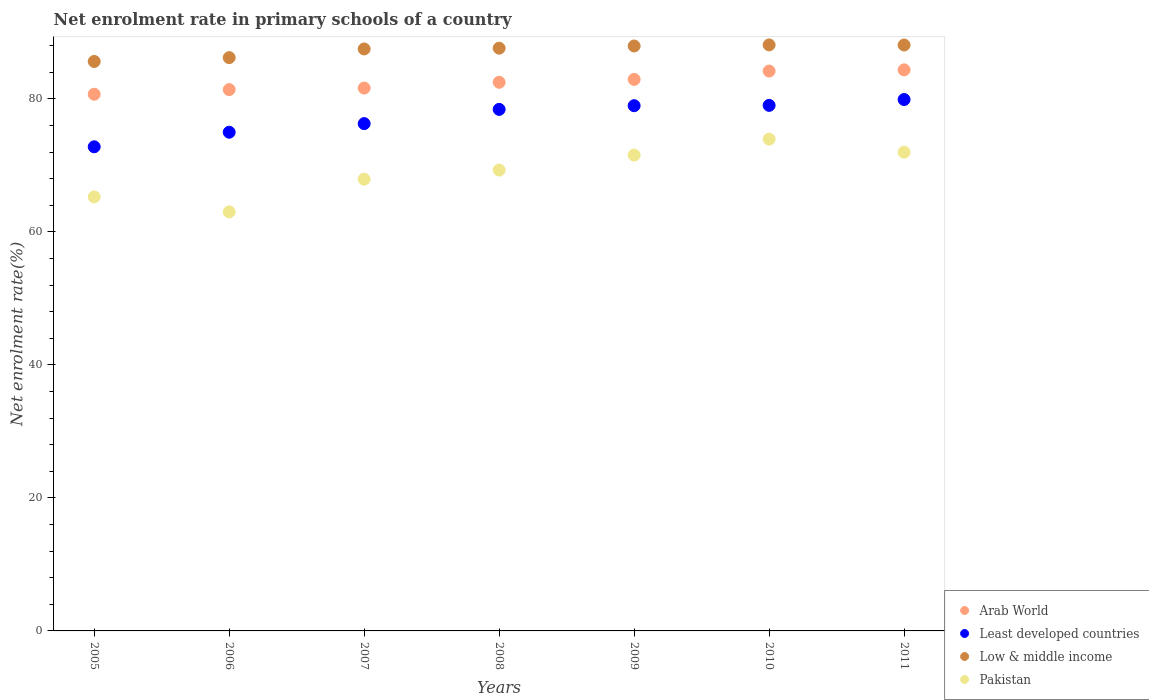Is the number of dotlines equal to the number of legend labels?
Make the answer very short. Yes. What is the net enrolment rate in primary schools in Least developed countries in 2005?
Give a very brief answer. 72.8. Across all years, what is the maximum net enrolment rate in primary schools in Pakistan?
Make the answer very short. 73.95. Across all years, what is the minimum net enrolment rate in primary schools in Pakistan?
Your response must be concise. 63.01. In which year was the net enrolment rate in primary schools in Least developed countries maximum?
Provide a succinct answer. 2011. In which year was the net enrolment rate in primary schools in Least developed countries minimum?
Ensure brevity in your answer.  2005. What is the total net enrolment rate in primary schools in Least developed countries in the graph?
Offer a very short reply. 540.4. What is the difference between the net enrolment rate in primary schools in Pakistan in 2005 and that in 2009?
Make the answer very short. -6.28. What is the difference between the net enrolment rate in primary schools in Low & middle income in 2011 and the net enrolment rate in primary schools in Pakistan in 2009?
Your answer should be very brief. 16.55. What is the average net enrolment rate in primary schools in Low & middle income per year?
Your answer should be compact. 87.31. In the year 2009, what is the difference between the net enrolment rate in primary schools in Arab World and net enrolment rate in primary schools in Least developed countries?
Provide a succinct answer. 3.96. In how many years, is the net enrolment rate in primary schools in Arab World greater than 20 %?
Offer a terse response. 7. What is the ratio of the net enrolment rate in primary schools in Pakistan in 2006 to that in 2007?
Keep it short and to the point. 0.93. What is the difference between the highest and the second highest net enrolment rate in primary schools in Pakistan?
Ensure brevity in your answer.  1.97. What is the difference between the highest and the lowest net enrolment rate in primary schools in Least developed countries?
Your answer should be very brief. 7.11. Is the sum of the net enrolment rate in primary schools in Least developed countries in 2005 and 2010 greater than the maximum net enrolment rate in primary schools in Low & middle income across all years?
Make the answer very short. Yes. Is it the case that in every year, the sum of the net enrolment rate in primary schools in Least developed countries and net enrolment rate in primary schools in Pakistan  is greater than the sum of net enrolment rate in primary schools in Low & middle income and net enrolment rate in primary schools in Arab World?
Provide a succinct answer. No. Is it the case that in every year, the sum of the net enrolment rate in primary schools in Pakistan and net enrolment rate in primary schools in Least developed countries  is greater than the net enrolment rate in primary schools in Low & middle income?
Provide a short and direct response. Yes. Is the net enrolment rate in primary schools in Low & middle income strictly less than the net enrolment rate in primary schools in Pakistan over the years?
Make the answer very short. No. How many years are there in the graph?
Your answer should be compact. 7. Does the graph contain any zero values?
Keep it short and to the point. No. Where does the legend appear in the graph?
Provide a succinct answer. Bottom right. How many legend labels are there?
Provide a succinct answer. 4. What is the title of the graph?
Make the answer very short. Net enrolment rate in primary schools of a country. Does "Japan" appear as one of the legend labels in the graph?
Provide a short and direct response. No. What is the label or title of the X-axis?
Offer a very short reply. Years. What is the label or title of the Y-axis?
Keep it short and to the point. Net enrolment rate(%). What is the Net enrolment rate(%) of Arab World in 2005?
Offer a very short reply. 80.7. What is the Net enrolment rate(%) of Least developed countries in 2005?
Offer a very short reply. 72.8. What is the Net enrolment rate(%) of Low & middle income in 2005?
Make the answer very short. 85.63. What is the Net enrolment rate(%) of Pakistan in 2005?
Your answer should be compact. 65.26. What is the Net enrolment rate(%) in Arab World in 2006?
Your response must be concise. 81.4. What is the Net enrolment rate(%) of Least developed countries in 2006?
Provide a short and direct response. 74.99. What is the Net enrolment rate(%) in Low & middle income in 2006?
Give a very brief answer. 86.2. What is the Net enrolment rate(%) of Pakistan in 2006?
Your response must be concise. 63.01. What is the Net enrolment rate(%) of Arab World in 2007?
Offer a very short reply. 81.63. What is the Net enrolment rate(%) of Least developed countries in 2007?
Offer a very short reply. 76.28. What is the Net enrolment rate(%) of Low & middle income in 2007?
Offer a terse response. 87.51. What is the Net enrolment rate(%) of Pakistan in 2007?
Offer a very short reply. 67.93. What is the Net enrolment rate(%) in Arab World in 2008?
Provide a short and direct response. 82.5. What is the Net enrolment rate(%) in Least developed countries in 2008?
Ensure brevity in your answer.  78.42. What is the Net enrolment rate(%) in Low & middle income in 2008?
Make the answer very short. 87.63. What is the Net enrolment rate(%) of Pakistan in 2008?
Your answer should be compact. 69.29. What is the Net enrolment rate(%) in Arab World in 2009?
Offer a very short reply. 82.93. What is the Net enrolment rate(%) of Least developed countries in 2009?
Your answer should be compact. 78.98. What is the Net enrolment rate(%) in Low & middle income in 2009?
Offer a terse response. 87.96. What is the Net enrolment rate(%) in Pakistan in 2009?
Keep it short and to the point. 71.55. What is the Net enrolment rate(%) of Arab World in 2010?
Provide a succinct answer. 84.19. What is the Net enrolment rate(%) of Least developed countries in 2010?
Make the answer very short. 79.03. What is the Net enrolment rate(%) of Low & middle income in 2010?
Give a very brief answer. 88.12. What is the Net enrolment rate(%) in Pakistan in 2010?
Provide a short and direct response. 73.95. What is the Net enrolment rate(%) of Arab World in 2011?
Give a very brief answer. 84.36. What is the Net enrolment rate(%) of Least developed countries in 2011?
Your answer should be very brief. 79.9. What is the Net enrolment rate(%) of Low & middle income in 2011?
Ensure brevity in your answer.  88.1. What is the Net enrolment rate(%) of Pakistan in 2011?
Provide a short and direct response. 71.98. Across all years, what is the maximum Net enrolment rate(%) in Arab World?
Offer a terse response. 84.36. Across all years, what is the maximum Net enrolment rate(%) of Least developed countries?
Your response must be concise. 79.9. Across all years, what is the maximum Net enrolment rate(%) of Low & middle income?
Keep it short and to the point. 88.12. Across all years, what is the maximum Net enrolment rate(%) of Pakistan?
Keep it short and to the point. 73.95. Across all years, what is the minimum Net enrolment rate(%) in Arab World?
Give a very brief answer. 80.7. Across all years, what is the minimum Net enrolment rate(%) in Least developed countries?
Provide a succinct answer. 72.8. Across all years, what is the minimum Net enrolment rate(%) in Low & middle income?
Your answer should be compact. 85.63. Across all years, what is the minimum Net enrolment rate(%) of Pakistan?
Your response must be concise. 63.01. What is the total Net enrolment rate(%) of Arab World in the graph?
Provide a short and direct response. 577.71. What is the total Net enrolment rate(%) of Least developed countries in the graph?
Provide a succinct answer. 540.4. What is the total Net enrolment rate(%) in Low & middle income in the graph?
Offer a very short reply. 611.14. What is the total Net enrolment rate(%) in Pakistan in the graph?
Your answer should be compact. 482.98. What is the difference between the Net enrolment rate(%) of Arab World in 2005 and that in 2006?
Your response must be concise. -0.7. What is the difference between the Net enrolment rate(%) in Least developed countries in 2005 and that in 2006?
Make the answer very short. -2.19. What is the difference between the Net enrolment rate(%) in Low & middle income in 2005 and that in 2006?
Offer a terse response. -0.57. What is the difference between the Net enrolment rate(%) of Pakistan in 2005 and that in 2006?
Keep it short and to the point. 2.25. What is the difference between the Net enrolment rate(%) of Arab World in 2005 and that in 2007?
Provide a short and direct response. -0.93. What is the difference between the Net enrolment rate(%) of Least developed countries in 2005 and that in 2007?
Offer a very short reply. -3.48. What is the difference between the Net enrolment rate(%) in Low & middle income in 2005 and that in 2007?
Ensure brevity in your answer.  -1.88. What is the difference between the Net enrolment rate(%) in Pakistan in 2005 and that in 2007?
Your response must be concise. -2.67. What is the difference between the Net enrolment rate(%) of Arab World in 2005 and that in 2008?
Your answer should be very brief. -1.8. What is the difference between the Net enrolment rate(%) of Least developed countries in 2005 and that in 2008?
Offer a terse response. -5.63. What is the difference between the Net enrolment rate(%) of Low & middle income in 2005 and that in 2008?
Your response must be concise. -2. What is the difference between the Net enrolment rate(%) of Pakistan in 2005 and that in 2008?
Make the answer very short. -4.03. What is the difference between the Net enrolment rate(%) of Arab World in 2005 and that in 2009?
Give a very brief answer. -2.23. What is the difference between the Net enrolment rate(%) of Least developed countries in 2005 and that in 2009?
Offer a very short reply. -6.18. What is the difference between the Net enrolment rate(%) in Low & middle income in 2005 and that in 2009?
Make the answer very short. -2.33. What is the difference between the Net enrolment rate(%) in Pakistan in 2005 and that in 2009?
Ensure brevity in your answer.  -6.28. What is the difference between the Net enrolment rate(%) of Arab World in 2005 and that in 2010?
Your answer should be compact. -3.49. What is the difference between the Net enrolment rate(%) in Least developed countries in 2005 and that in 2010?
Your answer should be compact. -6.23. What is the difference between the Net enrolment rate(%) in Low & middle income in 2005 and that in 2010?
Ensure brevity in your answer.  -2.49. What is the difference between the Net enrolment rate(%) in Pakistan in 2005 and that in 2010?
Make the answer very short. -8.69. What is the difference between the Net enrolment rate(%) in Arab World in 2005 and that in 2011?
Your answer should be very brief. -3.67. What is the difference between the Net enrolment rate(%) of Least developed countries in 2005 and that in 2011?
Your answer should be very brief. -7.11. What is the difference between the Net enrolment rate(%) of Low & middle income in 2005 and that in 2011?
Provide a short and direct response. -2.47. What is the difference between the Net enrolment rate(%) in Pakistan in 2005 and that in 2011?
Offer a very short reply. -6.72. What is the difference between the Net enrolment rate(%) of Arab World in 2006 and that in 2007?
Keep it short and to the point. -0.23. What is the difference between the Net enrolment rate(%) of Least developed countries in 2006 and that in 2007?
Ensure brevity in your answer.  -1.29. What is the difference between the Net enrolment rate(%) of Low & middle income in 2006 and that in 2007?
Your response must be concise. -1.31. What is the difference between the Net enrolment rate(%) in Pakistan in 2006 and that in 2007?
Provide a short and direct response. -4.92. What is the difference between the Net enrolment rate(%) of Arab World in 2006 and that in 2008?
Offer a terse response. -1.1. What is the difference between the Net enrolment rate(%) in Least developed countries in 2006 and that in 2008?
Provide a short and direct response. -3.44. What is the difference between the Net enrolment rate(%) of Low & middle income in 2006 and that in 2008?
Offer a very short reply. -1.42. What is the difference between the Net enrolment rate(%) of Pakistan in 2006 and that in 2008?
Keep it short and to the point. -6.28. What is the difference between the Net enrolment rate(%) of Arab World in 2006 and that in 2009?
Keep it short and to the point. -1.54. What is the difference between the Net enrolment rate(%) in Least developed countries in 2006 and that in 2009?
Provide a short and direct response. -3.99. What is the difference between the Net enrolment rate(%) in Low & middle income in 2006 and that in 2009?
Give a very brief answer. -1.75. What is the difference between the Net enrolment rate(%) in Pakistan in 2006 and that in 2009?
Make the answer very short. -8.53. What is the difference between the Net enrolment rate(%) of Arab World in 2006 and that in 2010?
Provide a short and direct response. -2.79. What is the difference between the Net enrolment rate(%) in Least developed countries in 2006 and that in 2010?
Your answer should be very brief. -4.04. What is the difference between the Net enrolment rate(%) of Low & middle income in 2006 and that in 2010?
Keep it short and to the point. -1.91. What is the difference between the Net enrolment rate(%) of Pakistan in 2006 and that in 2010?
Keep it short and to the point. -10.94. What is the difference between the Net enrolment rate(%) of Arab World in 2006 and that in 2011?
Give a very brief answer. -2.97. What is the difference between the Net enrolment rate(%) in Least developed countries in 2006 and that in 2011?
Your answer should be very brief. -4.92. What is the difference between the Net enrolment rate(%) of Low & middle income in 2006 and that in 2011?
Your response must be concise. -1.9. What is the difference between the Net enrolment rate(%) in Pakistan in 2006 and that in 2011?
Your answer should be compact. -8.97. What is the difference between the Net enrolment rate(%) in Arab World in 2007 and that in 2008?
Offer a very short reply. -0.87. What is the difference between the Net enrolment rate(%) in Least developed countries in 2007 and that in 2008?
Your answer should be compact. -2.14. What is the difference between the Net enrolment rate(%) in Low & middle income in 2007 and that in 2008?
Offer a very short reply. -0.12. What is the difference between the Net enrolment rate(%) of Pakistan in 2007 and that in 2008?
Provide a succinct answer. -1.36. What is the difference between the Net enrolment rate(%) in Arab World in 2007 and that in 2009?
Your answer should be very brief. -1.31. What is the difference between the Net enrolment rate(%) in Least developed countries in 2007 and that in 2009?
Your answer should be compact. -2.7. What is the difference between the Net enrolment rate(%) of Low & middle income in 2007 and that in 2009?
Keep it short and to the point. -0.45. What is the difference between the Net enrolment rate(%) in Pakistan in 2007 and that in 2009?
Make the answer very short. -3.62. What is the difference between the Net enrolment rate(%) in Arab World in 2007 and that in 2010?
Your response must be concise. -2.56. What is the difference between the Net enrolment rate(%) of Least developed countries in 2007 and that in 2010?
Provide a succinct answer. -2.74. What is the difference between the Net enrolment rate(%) in Low & middle income in 2007 and that in 2010?
Your answer should be compact. -0.61. What is the difference between the Net enrolment rate(%) of Pakistan in 2007 and that in 2010?
Keep it short and to the point. -6.02. What is the difference between the Net enrolment rate(%) in Arab World in 2007 and that in 2011?
Keep it short and to the point. -2.74. What is the difference between the Net enrolment rate(%) of Least developed countries in 2007 and that in 2011?
Ensure brevity in your answer.  -3.62. What is the difference between the Net enrolment rate(%) of Low & middle income in 2007 and that in 2011?
Your answer should be compact. -0.59. What is the difference between the Net enrolment rate(%) in Pakistan in 2007 and that in 2011?
Your response must be concise. -4.05. What is the difference between the Net enrolment rate(%) in Arab World in 2008 and that in 2009?
Offer a very short reply. -0.44. What is the difference between the Net enrolment rate(%) in Least developed countries in 2008 and that in 2009?
Make the answer very short. -0.55. What is the difference between the Net enrolment rate(%) of Low & middle income in 2008 and that in 2009?
Provide a short and direct response. -0.33. What is the difference between the Net enrolment rate(%) of Pakistan in 2008 and that in 2009?
Your answer should be compact. -2.25. What is the difference between the Net enrolment rate(%) of Arab World in 2008 and that in 2010?
Your answer should be compact. -1.69. What is the difference between the Net enrolment rate(%) of Least developed countries in 2008 and that in 2010?
Your answer should be compact. -0.6. What is the difference between the Net enrolment rate(%) of Low & middle income in 2008 and that in 2010?
Your response must be concise. -0.49. What is the difference between the Net enrolment rate(%) in Pakistan in 2008 and that in 2010?
Keep it short and to the point. -4.66. What is the difference between the Net enrolment rate(%) of Arab World in 2008 and that in 2011?
Your response must be concise. -1.87. What is the difference between the Net enrolment rate(%) of Least developed countries in 2008 and that in 2011?
Offer a very short reply. -1.48. What is the difference between the Net enrolment rate(%) in Low & middle income in 2008 and that in 2011?
Your answer should be compact. -0.48. What is the difference between the Net enrolment rate(%) in Pakistan in 2008 and that in 2011?
Your response must be concise. -2.69. What is the difference between the Net enrolment rate(%) in Arab World in 2009 and that in 2010?
Give a very brief answer. -1.26. What is the difference between the Net enrolment rate(%) of Least developed countries in 2009 and that in 2010?
Make the answer very short. -0.05. What is the difference between the Net enrolment rate(%) in Low & middle income in 2009 and that in 2010?
Make the answer very short. -0.16. What is the difference between the Net enrolment rate(%) of Pakistan in 2009 and that in 2010?
Make the answer very short. -2.4. What is the difference between the Net enrolment rate(%) of Arab World in 2009 and that in 2011?
Make the answer very short. -1.43. What is the difference between the Net enrolment rate(%) in Least developed countries in 2009 and that in 2011?
Ensure brevity in your answer.  -0.93. What is the difference between the Net enrolment rate(%) in Low & middle income in 2009 and that in 2011?
Your answer should be compact. -0.15. What is the difference between the Net enrolment rate(%) in Pakistan in 2009 and that in 2011?
Your answer should be compact. -0.44. What is the difference between the Net enrolment rate(%) in Arab World in 2010 and that in 2011?
Your answer should be compact. -0.17. What is the difference between the Net enrolment rate(%) of Least developed countries in 2010 and that in 2011?
Offer a very short reply. -0.88. What is the difference between the Net enrolment rate(%) of Low & middle income in 2010 and that in 2011?
Offer a terse response. 0.01. What is the difference between the Net enrolment rate(%) of Pakistan in 2010 and that in 2011?
Make the answer very short. 1.97. What is the difference between the Net enrolment rate(%) in Arab World in 2005 and the Net enrolment rate(%) in Least developed countries in 2006?
Provide a succinct answer. 5.71. What is the difference between the Net enrolment rate(%) of Arab World in 2005 and the Net enrolment rate(%) of Low & middle income in 2006?
Give a very brief answer. -5.51. What is the difference between the Net enrolment rate(%) in Arab World in 2005 and the Net enrolment rate(%) in Pakistan in 2006?
Your answer should be very brief. 17.68. What is the difference between the Net enrolment rate(%) in Least developed countries in 2005 and the Net enrolment rate(%) in Low & middle income in 2006?
Ensure brevity in your answer.  -13.41. What is the difference between the Net enrolment rate(%) in Least developed countries in 2005 and the Net enrolment rate(%) in Pakistan in 2006?
Provide a succinct answer. 9.78. What is the difference between the Net enrolment rate(%) in Low & middle income in 2005 and the Net enrolment rate(%) in Pakistan in 2006?
Ensure brevity in your answer.  22.62. What is the difference between the Net enrolment rate(%) in Arab World in 2005 and the Net enrolment rate(%) in Least developed countries in 2007?
Ensure brevity in your answer.  4.42. What is the difference between the Net enrolment rate(%) in Arab World in 2005 and the Net enrolment rate(%) in Low & middle income in 2007?
Offer a very short reply. -6.81. What is the difference between the Net enrolment rate(%) of Arab World in 2005 and the Net enrolment rate(%) of Pakistan in 2007?
Make the answer very short. 12.77. What is the difference between the Net enrolment rate(%) of Least developed countries in 2005 and the Net enrolment rate(%) of Low & middle income in 2007?
Give a very brief answer. -14.71. What is the difference between the Net enrolment rate(%) in Least developed countries in 2005 and the Net enrolment rate(%) in Pakistan in 2007?
Your answer should be compact. 4.87. What is the difference between the Net enrolment rate(%) in Low & middle income in 2005 and the Net enrolment rate(%) in Pakistan in 2007?
Ensure brevity in your answer.  17.7. What is the difference between the Net enrolment rate(%) of Arab World in 2005 and the Net enrolment rate(%) of Least developed countries in 2008?
Provide a short and direct response. 2.28. What is the difference between the Net enrolment rate(%) of Arab World in 2005 and the Net enrolment rate(%) of Low & middle income in 2008?
Keep it short and to the point. -6.93. What is the difference between the Net enrolment rate(%) of Arab World in 2005 and the Net enrolment rate(%) of Pakistan in 2008?
Give a very brief answer. 11.4. What is the difference between the Net enrolment rate(%) of Least developed countries in 2005 and the Net enrolment rate(%) of Low & middle income in 2008?
Provide a short and direct response. -14.83. What is the difference between the Net enrolment rate(%) in Least developed countries in 2005 and the Net enrolment rate(%) in Pakistan in 2008?
Your response must be concise. 3.5. What is the difference between the Net enrolment rate(%) in Low & middle income in 2005 and the Net enrolment rate(%) in Pakistan in 2008?
Offer a very short reply. 16.33. What is the difference between the Net enrolment rate(%) of Arab World in 2005 and the Net enrolment rate(%) of Least developed countries in 2009?
Provide a succinct answer. 1.72. What is the difference between the Net enrolment rate(%) in Arab World in 2005 and the Net enrolment rate(%) in Low & middle income in 2009?
Provide a short and direct response. -7.26. What is the difference between the Net enrolment rate(%) of Arab World in 2005 and the Net enrolment rate(%) of Pakistan in 2009?
Provide a short and direct response. 9.15. What is the difference between the Net enrolment rate(%) of Least developed countries in 2005 and the Net enrolment rate(%) of Low & middle income in 2009?
Give a very brief answer. -15.16. What is the difference between the Net enrolment rate(%) in Least developed countries in 2005 and the Net enrolment rate(%) in Pakistan in 2009?
Provide a short and direct response. 1.25. What is the difference between the Net enrolment rate(%) in Low & middle income in 2005 and the Net enrolment rate(%) in Pakistan in 2009?
Ensure brevity in your answer.  14.08. What is the difference between the Net enrolment rate(%) in Arab World in 2005 and the Net enrolment rate(%) in Least developed countries in 2010?
Give a very brief answer. 1.67. What is the difference between the Net enrolment rate(%) of Arab World in 2005 and the Net enrolment rate(%) of Low & middle income in 2010?
Offer a terse response. -7.42. What is the difference between the Net enrolment rate(%) in Arab World in 2005 and the Net enrolment rate(%) in Pakistan in 2010?
Your answer should be very brief. 6.75. What is the difference between the Net enrolment rate(%) of Least developed countries in 2005 and the Net enrolment rate(%) of Low & middle income in 2010?
Give a very brief answer. -15.32. What is the difference between the Net enrolment rate(%) of Least developed countries in 2005 and the Net enrolment rate(%) of Pakistan in 2010?
Your answer should be very brief. -1.15. What is the difference between the Net enrolment rate(%) of Low & middle income in 2005 and the Net enrolment rate(%) of Pakistan in 2010?
Your answer should be very brief. 11.68. What is the difference between the Net enrolment rate(%) of Arab World in 2005 and the Net enrolment rate(%) of Least developed countries in 2011?
Make the answer very short. 0.79. What is the difference between the Net enrolment rate(%) in Arab World in 2005 and the Net enrolment rate(%) in Low & middle income in 2011?
Give a very brief answer. -7.4. What is the difference between the Net enrolment rate(%) of Arab World in 2005 and the Net enrolment rate(%) of Pakistan in 2011?
Keep it short and to the point. 8.71. What is the difference between the Net enrolment rate(%) of Least developed countries in 2005 and the Net enrolment rate(%) of Low & middle income in 2011?
Make the answer very short. -15.3. What is the difference between the Net enrolment rate(%) of Least developed countries in 2005 and the Net enrolment rate(%) of Pakistan in 2011?
Provide a succinct answer. 0.81. What is the difference between the Net enrolment rate(%) in Low & middle income in 2005 and the Net enrolment rate(%) in Pakistan in 2011?
Offer a very short reply. 13.64. What is the difference between the Net enrolment rate(%) in Arab World in 2006 and the Net enrolment rate(%) in Least developed countries in 2007?
Your answer should be compact. 5.11. What is the difference between the Net enrolment rate(%) of Arab World in 2006 and the Net enrolment rate(%) of Low & middle income in 2007?
Make the answer very short. -6.11. What is the difference between the Net enrolment rate(%) in Arab World in 2006 and the Net enrolment rate(%) in Pakistan in 2007?
Provide a succinct answer. 13.47. What is the difference between the Net enrolment rate(%) in Least developed countries in 2006 and the Net enrolment rate(%) in Low & middle income in 2007?
Provide a short and direct response. -12.52. What is the difference between the Net enrolment rate(%) in Least developed countries in 2006 and the Net enrolment rate(%) in Pakistan in 2007?
Offer a terse response. 7.06. What is the difference between the Net enrolment rate(%) of Low & middle income in 2006 and the Net enrolment rate(%) of Pakistan in 2007?
Your answer should be very brief. 18.27. What is the difference between the Net enrolment rate(%) in Arab World in 2006 and the Net enrolment rate(%) in Least developed countries in 2008?
Your response must be concise. 2.97. What is the difference between the Net enrolment rate(%) of Arab World in 2006 and the Net enrolment rate(%) of Low & middle income in 2008?
Provide a succinct answer. -6.23. What is the difference between the Net enrolment rate(%) of Arab World in 2006 and the Net enrolment rate(%) of Pakistan in 2008?
Offer a terse response. 12.1. What is the difference between the Net enrolment rate(%) of Least developed countries in 2006 and the Net enrolment rate(%) of Low & middle income in 2008?
Make the answer very short. -12.64. What is the difference between the Net enrolment rate(%) in Least developed countries in 2006 and the Net enrolment rate(%) in Pakistan in 2008?
Your answer should be compact. 5.69. What is the difference between the Net enrolment rate(%) in Low & middle income in 2006 and the Net enrolment rate(%) in Pakistan in 2008?
Provide a short and direct response. 16.91. What is the difference between the Net enrolment rate(%) in Arab World in 2006 and the Net enrolment rate(%) in Least developed countries in 2009?
Your response must be concise. 2.42. What is the difference between the Net enrolment rate(%) in Arab World in 2006 and the Net enrolment rate(%) in Low & middle income in 2009?
Offer a very short reply. -6.56. What is the difference between the Net enrolment rate(%) in Arab World in 2006 and the Net enrolment rate(%) in Pakistan in 2009?
Ensure brevity in your answer.  9.85. What is the difference between the Net enrolment rate(%) of Least developed countries in 2006 and the Net enrolment rate(%) of Low & middle income in 2009?
Make the answer very short. -12.97. What is the difference between the Net enrolment rate(%) in Least developed countries in 2006 and the Net enrolment rate(%) in Pakistan in 2009?
Keep it short and to the point. 3.44. What is the difference between the Net enrolment rate(%) of Low & middle income in 2006 and the Net enrolment rate(%) of Pakistan in 2009?
Make the answer very short. 14.66. What is the difference between the Net enrolment rate(%) of Arab World in 2006 and the Net enrolment rate(%) of Least developed countries in 2010?
Your answer should be compact. 2.37. What is the difference between the Net enrolment rate(%) in Arab World in 2006 and the Net enrolment rate(%) in Low & middle income in 2010?
Make the answer very short. -6.72. What is the difference between the Net enrolment rate(%) of Arab World in 2006 and the Net enrolment rate(%) of Pakistan in 2010?
Offer a very short reply. 7.44. What is the difference between the Net enrolment rate(%) of Least developed countries in 2006 and the Net enrolment rate(%) of Low & middle income in 2010?
Offer a very short reply. -13.13. What is the difference between the Net enrolment rate(%) in Least developed countries in 2006 and the Net enrolment rate(%) in Pakistan in 2010?
Give a very brief answer. 1.04. What is the difference between the Net enrolment rate(%) of Low & middle income in 2006 and the Net enrolment rate(%) of Pakistan in 2010?
Offer a terse response. 12.25. What is the difference between the Net enrolment rate(%) in Arab World in 2006 and the Net enrolment rate(%) in Least developed countries in 2011?
Your response must be concise. 1.49. What is the difference between the Net enrolment rate(%) in Arab World in 2006 and the Net enrolment rate(%) in Low & middle income in 2011?
Give a very brief answer. -6.71. What is the difference between the Net enrolment rate(%) of Arab World in 2006 and the Net enrolment rate(%) of Pakistan in 2011?
Provide a succinct answer. 9.41. What is the difference between the Net enrolment rate(%) of Least developed countries in 2006 and the Net enrolment rate(%) of Low & middle income in 2011?
Give a very brief answer. -13.11. What is the difference between the Net enrolment rate(%) in Least developed countries in 2006 and the Net enrolment rate(%) in Pakistan in 2011?
Provide a succinct answer. 3. What is the difference between the Net enrolment rate(%) of Low & middle income in 2006 and the Net enrolment rate(%) of Pakistan in 2011?
Your response must be concise. 14.22. What is the difference between the Net enrolment rate(%) in Arab World in 2007 and the Net enrolment rate(%) in Least developed countries in 2008?
Give a very brief answer. 3.2. What is the difference between the Net enrolment rate(%) in Arab World in 2007 and the Net enrolment rate(%) in Low & middle income in 2008?
Your response must be concise. -6. What is the difference between the Net enrolment rate(%) of Arab World in 2007 and the Net enrolment rate(%) of Pakistan in 2008?
Your answer should be very brief. 12.33. What is the difference between the Net enrolment rate(%) in Least developed countries in 2007 and the Net enrolment rate(%) in Low & middle income in 2008?
Your answer should be very brief. -11.34. What is the difference between the Net enrolment rate(%) in Least developed countries in 2007 and the Net enrolment rate(%) in Pakistan in 2008?
Ensure brevity in your answer.  6.99. What is the difference between the Net enrolment rate(%) in Low & middle income in 2007 and the Net enrolment rate(%) in Pakistan in 2008?
Your answer should be compact. 18.22. What is the difference between the Net enrolment rate(%) in Arab World in 2007 and the Net enrolment rate(%) in Least developed countries in 2009?
Offer a terse response. 2.65. What is the difference between the Net enrolment rate(%) of Arab World in 2007 and the Net enrolment rate(%) of Low & middle income in 2009?
Your answer should be very brief. -6.33. What is the difference between the Net enrolment rate(%) in Arab World in 2007 and the Net enrolment rate(%) in Pakistan in 2009?
Provide a succinct answer. 10.08. What is the difference between the Net enrolment rate(%) in Least developed countries in 2007 and the Net enrolment rate(%) in Low & middle income in 2009?
Your answer should be compact. -11.67. What is the difference between the Net enrolment rate(%) of Least developed countries in 2007 and the Net enrolment rate(%) of Pakistan in 2009?
Make the answer very short. 4.74. What is the difference between the Net enrolment rate(%) in Low & middle income in 2007 and the Net enrolment rate(%) in Pakistan in 2009?
Give a very brief answer. 15.96. What is the difference between the Net enrolment rate(%) in Arab World in 2007 and the Net enrolment rate(%) in Least developed countries in 2010?
Provide a succinct answer. 2.6. What is the difference between the Net enrolment rate(%) in Arab World in 2007 and the Net enrolment rate(%) in Low & middle income in 2010?
Make the answer very short. -6.49. What is the difference between the Net enrolment rate(%) of Arab World in 2007 and the Net enrolment rate(%) of Pakistan in 2010?
Give a very brief answer. 7.68. What is the difference between the Net enrolment rate(%) in Least developed countries in 2007 and the Net enrolment rate(%) in Low & middle income in 2010?
Your answer should be very brief. -11.83. What is the difference between the Net enrolment rate(%) in Least developed countries in 2007 and the Net enrolment rate(%) in Pakistan in 2010?
Ensure brevity in your answer.  2.33. What is the difference between the Net enrolment rate(%) in Low & middle income in 2007 and the Net enrolment rate(%) in Pakistan in 2010?
Offer a very short reply. 13.56. What is the difference between the Net enrolment rate(%) of Arab World in 2007 and the Net enrolment rate(%) of Least developed countries in 2011?
Provide a short and direct response. 1.72. What is the difference between the Net enrolment rate(%) of Arab World in 2007 and the Net enrolment rate(%) of Low & middle income in 2011?
Provide a succinct answer. -6.47. What is the difference between the Net enrolment rate(%) of Arab World in 2007 and the Net enrolment rate(%) of Pakistan in 2011?
Offer a very short reply. 9.64. What is the difference between the Net enrolment rate(%) in Least developed countries in 2007 and the Net enrolment rate(%) in Low & middle income in 2011?
Your answer should be very brief. -11.82. What is the difference between the Net enrolment rate(%) in Least developed countries in 2007 and the Net enrolment rate(%) in Pakistan in 2011?
Ensure brevity in your answer.  4.3. What is the difference between the Net enrolment rate(%) in Low & middle income in 2007 and the Net enrolment rate(%) in Pakistan in 2011?
Your answer should be compact. 15.53. What is the difference between the Net enrolment rate(%) in Arab World in 2008 and the Net enrolment rate(%) in Least developed countries in 2009?
Provide a succinct answer. 3.52. What is the difference between the Net enrolment rate(%) of Arab World in 2008 and the Net enrolment rate(%) of Low & middle income in 2009?
Provide a short and direct response. -5.46. What is the difference between the Net enrolment rate(%) in Arab World in 2008 and the Net enrolment rate(%) in Pakistan in 2009?
Keep it short and to the point. 10.95. What is the difference between the Net enrolment rate(%) of Least developed countries in 2008 and the Net enrolment rate(%) of Low & middle income in 2009?
Ensure brevity in your answer.  -9.53. What is the difference between the Net enrolment rate(%) in Least developed countries in 2008 and the Net enrolment rate(%) in Pakistan in 2009?
Offer a terse response. 6.88. What is the difference between the Net enrolment rate(%) in Low & middle income in 2008 and the Net enrolment rate(%) in Pakistan in 2009?
Offer a very short reply. 16.08. What is the difference between the Net enrolment rate(%) of Arab World in 2008 and the Net enrolment rate(%) of Least developed countries in 2010?
Offer a very short reply. 3.47. What is the difference between the Net enrolment rate(%) of Arab World in 2008 and the Net enrolment rate(%) of Low & middle income in 2010?
Give a very brief answer. -5.62. What is the difference between the Net enrolment rate(%) of Arab World in 2008 and the Net enrolment rate(%) of Pakistan in 2010?
Offer a terse response. 8.55. What is the difference between the Net enrolment rate(%) of Least developed countries in 2008 and the Net enrolment rate(%) of Low & middle income in 2010?
Offer a very short reply. -9.69. What is the difference between the Net enrolment rate(%) of Least developed countries in 2008 and the Net enrolment rate(%) of Pakistan in 2010?
Offer a terse response. 4.47. What is the difference between the Net enrolment rate(%) in Low & middle income in 2008 and the Net enrolment rate(%) in Pakistan in 2010?
Provide a short and direct response. 13.67. What is the difference between the Net enrolment rate(%) in Arab World in 2008 and the Net enrolment rate(%) in Least developed countries in 2011?
Offer a terse response. 2.59. What is the difference between the Net enrolment rate(%) in Arab World in 2008 and the Net enrolment rate(%) in Low & middle income in 2011?
Ensure brevity in your answer.  -5.6. What is the difference between the Net enrolment rate(%) in Arab World in 2008 and the Net enrolment rate(%) in Pakistan in 2011?
Your answer should be compact. 10.51. What is the difference between the Net enrolment rate(%) of Least developed countries in 2008 and the Net enrolment rate(%) of Low & middle income in 2011?
Give a very brief answer. -9.68. What is the difference between the Net enrolment rate(%) in Least developed countries in 2008 and the Net enrolment rate(%) in Pakistan in 2011?
Offer a very short reply. 6.44. What is the difference between the Net enrolment rate(%) in Low & middle income in 2008 and the Net enrolment rate(%) in Pakistan in 2011?
Your answer should be very brief. 15.64. What is the difference between the Net enrolment rate(%) of Arab World in 2009 and the Net enrolment rate(%) of Least developed countries in 2010?
Ensure brevity in your answer.  3.91. What is the difference between the Net enrolment rate(%) of Arab World in 2009 and the Net enrolment rate(%) of Low & middle income in 2010?
Your answer should be compact. -5.18. What is the difference between the Net enrolment rate(%) in Arab World in 2009 and the Net enrolment rate(%) in Pakistan in 2010?
Your answer should be very brief. 8.98. What is the difference between the Net enrolment rate(%) in Least developed countries in 2009 and the Net enrolment rate(%) in Low & middle income in 2010?
Offer a very short reply. -9.14. What is the difference between the Net enrolment rate(%) of Least developed countries in 2009 and the Net enrolment rate(%) of Pakistan in 2010?
Your answer should be compact. 5.03. What is the difference between the Net enrolment rate(%) in Low & middle income in 2009 and the Net enrolment rate(%) in Pakistan in 2010?
Your answer should be compact. 14. What is the difference between the Net enrolment rate(%) in Arab World in 2009 and the Net enrolment rate(%) in Least developed countries in 2011?
Provide a succinct answer. 3.03. What is the difference between the Net enrolment rate(%) in Arab World in 2009 and the Net enrolment rate(%) in Low & middle income in 2011?
Provide a short and direct response. -5.17. What is the difference between the Net enrolment rate(%) in Arab World in 2009 and the Net enrolment rate(%) in Pakistan in 2011?
Keep it short and to the point. 10.95. What is the difference between the Net enrolment rate(%) in Least developed countries in 2009 and the Net enrolment rate(%) in Low & middle income in 2011?
Ensure brevity in your answer.  -9.12. What is the difference between the Net enrolment rate(%) of Least developed countries in 2009 and the Net enrolment rate(%) of Pakistan in 2011?
Offer a very short reply. 6.99. What is the difference between the Net enrolment rate(%) of Low & middle income in 2009 and the Net enrolment rate(%) of Pakistan in 2011?
Offer a terse response. 15.97. What is the difference between the Net enrolment rate(%) of Arab World in 2010 and the Net enrolment rate(%) of Least developed countries in 2011?
Your response must be concise. 4.29. What is the difference between the Net enrolment rate(%) in Arab World in 2010 and the Net enrolment rate(%) in Low & middle income in 2011?
Provide a short and direct response. -3.91. What is the difference between the Net enrolment rate(%) of Arab World in 2010 and the Net enrolment rate(%) of Pakistan in 2011?
Make the answer very short. 12.21. What is the difference between the Net enrolment rate(%) in Least developed countries in 2010 and the Net enrolment rate(%) in Low & middle income in 2011?
Ensure brevity in your answer.  -9.08. What is the difference between the Net enrolment rate(%) of Least developed countries in 2010 and the Net enrolment rate(%) of Pakistan in 2011?
Give a very brief answer. 7.04. What is the difference between the Net enrolment rate(%) of Low & middle income in 2010 and the Net enrolment rate(%) of Pakistan in 2011?
Offer a terse response. 16.13. What is the average Net enrolment rate(%) in Arab World per year?
Ensure brevity in your answer.  82.53. What is the average Net enrolment rate(%) in Least developed countries per year?
Provide a succinct answer. 77.2. What is the average Net enrolment rate(%) in Low & middle income per year?
Ensure brevity in your answer.  87.31. What is the average Net enrolment rate(%) in Pakistan per year?
Make the answer very short. 69. In the year 2005, what is the difference between the Net enrolment rate(%) in Arab World and Net enrolment rate(%) in Least developed countries?
Give a very brief answer. 7.9. In the year 2005, what is the difference between the Net enrolment rate(%) of Arab World and Net enrolment rate(%) of Low & middle income?
Offer a very short reply. -4.93. In the year 2005, what is the difference between the Net enrolment rate(%) of Arab World and Net enrolment rate(%) of Pakistan?
Provide a short and direct response. 15.44. In the year 2005, what is the difference between the Net enrolment rate(%) of Least developed countries and Net enrolment rate(%) of Low & middle income?
Offer a terse response. -12.83. In the year 2005, what is the difference between the Net enrolment rate(%) of Least developed countries and Net enrolment rate(%) of Pakistan?
Ensure brevity in your answer.  7.53. In the year 2005, what is the difference between the Net enrolment rate(%) of Low & middle income and Net enrolment rate(%) of Pakistan?
Offer a very short reply. 20.37. In the year 2006, what is the difference between the Net enrolment rate(%) in Arab World and Net enrolment rate(%) in Least developed countries?
Your answer should be compact. 6.41. In the year 2006, what is the difference between the Net enrolment rate(%) in Arab World and Net enrolment rate(%) in Low & middle income?
Offer a terse response. -4.81. In the year 2006, what is the difference between the Net enrolment rate(%) in Arab World and Net enrolment rate(%) in Pakistan?
Ensure brevity in your answer.  18.38. In the year 2006, what is the difference between the Net enrolment rate(%) in Least developed countries and Net enrolment rate(%) in Low & middle income?
Offer a very short reply. -11.22. In the year 2006, what is the difference between the Net enrolment rate(%) of Least developed countries and Net enrolment rate(%) of Pakistan?
Offer a terse response. 11.97. In the year 2006, what is the difference between the Net enrolment rate(%) of Low & middle income and Net enrolment rate(%) of Pakistan?
Offer a terse response. 23.19. In the year 2007, what is the difference between the Net enrolment rate(%) in Arab World and Net enrolment rate(%) in Least developed countries?
Provide a succinct answer. 5.35. In the year 2007, what is the difference between the Net enrolment rate(%) in Arab World and Net enrolment rate(%) in Low & middle income?
Your response must be concise. -5.88. In the year 2007, what is the difference between the Net enrolment rate(%) of Arab World and Net enrolment rate(%) of Pakistan?
Give a very brief answer. 13.7. In the year 2007, what is the difference between the Net enrolment rate(%) in Least developed countries and Net enrolment rate(%) in Low & middle income?
Make the answer very short. -11.23. In the year 2007, what is the difference between the Net enrolment rate(%) of Least developed countries and Net enrolment rate(%) of Pakistan?
Provide a short and direct response. 8.35. In the year 2007, what is the difference between the Net enrolment rate(%) of Low & middle income and Net enrolment rate(%) of Pakistan?
Keep it short and to the point. 19.58. In the year 2008, what is the difference between the Net enrolment rate(%) of Arab World and Net enrolment rate(%) of Least developed countries?
Your response must be concise. 4.07. In the year 2008, what is the difference between the Net enrolment rate(%) in Arab World and Net enrolment rate(%) in Low & middle income?
Make the answer very short. -5.13. In the year 2008, what is the difference between the Net enrolment rate(%) in Arab World and Net enrolment rate(%) in Pakistan?
Keep it short and to the point. 13.2. In the year 2008, what is the difference between the Net enrolment rate(%) of Least developed countries and Net enrolment rate(%) of Low & middle income?
Ensure brevity in your answer.  -9.2. In the year 2008, what is the difference between the Net enrolment rate(%) in Least developed countries and Net enrolment rate(%) in Pakistan?
Give a very brief answer. 9.13. In the year 2008, what is the difference between the Net enrolment rate(%) in Low & middle income and Net enrolment rate(%) in Pakistan?
Give a very brief answer. 18.33. In the year 2009, what is the difference between the Net enrolment rate(%) of Arab World and Net enrolment rate(%) of Least developed countries?
Provide a short and direct response. 3.96. In the year 2009, what is the difference between the Net enrolment rate(%) in Arab World and Net enrolment rate(%) in Low & middle income?
Offer a terse response. -5.02. In the year 2009, what is the difference between the Net enrolment rate(%) in Arab World and Net enrolment rate(%) in Pakistan?
Offer a terse response. 11.39. In the year 2009, what is the difference between the Net enrolment rate(%) in Least developed countries and Net enrolment rate(%) in Low & middle income?
Provide a short and direct response. -8.98. In the year 2009, what is the difference between the Net enrolment rate(%) in Least developed countries and Net enrolment rate(%) in Pakistan?
Make the answer very short. 7.43. In the year 2009, what is the difference between the Net enrolment rate(%) in Low & middle income and Net enrolment rate(%) in Pakistan?
Your response must be concise. 16.41. In the year 2010, what is the difference between the Net enrolment rate(%) of Arab World and Net enrolment rate(%) of Least developed countries?
Your response must be concise. 5.16. In the year 2010, what is the difference between the Net enrolment rate(%) of Arab World and Net enrolment rate(%) of Low & middle income?
Your response must be concise. -3.93. In the year 2010, what is the difference between the Net enrolment rate(%) in Arab World and Net enrolment rate(%) in Pakistan?
Make the answer very short. 10.24. In the year 2010, what is the difference between the Net enrolment rate(%) in Least developed countries and Net enrolment rate(%) in Low & middle income?
Your response must be concise. -9.09. In the year 2010, what is the difference between the Net enrolment rate(%) of Least developed countries and Net enrolment rate(%) of Pakistan?
Your answer should be very brief. 5.07. In the year 2010, what is the difference between the Net enrolment rate(%) in Low & middle income and Net enrolment rate(%) in Pakistan?
Provide a short and direct response. 14.16. In the year 2011, what is the difference between the Net enrolment rate(%) of Arab World and Net enrolment rate(%) of Least developed countries?
Make the answer very short. 4.46. In the year 2011, what is the difference between the Net enrolment rate(%) in Arab World and Net enrolment rate(%) in Low & middle income?
Provide a short and direct response. -3.74. In the year 2011, what is the difference between the Net enrolment rate(%) in Arab World and Net enrolment rate(%) in Pakistan?
Ensure brevity in your answer.  12.38. In the year 2011, what is the difference between the Net enrolment rate(%) of Least developed countries and Net enrolment rate(%) of Low & middle income?
Make the answer very short. -8.2. In the year 2011, what is the difference between the Net enrolment rate(%) of Least developed countries and Net enrolment rate(%) of Pakistan?
Your answer should be compact. 7.92. In the year 2011, what is the difference between the Net enrolment rate(%) of Low & middle income and Net enrolment rate(%) of Pakistan?
Give a very brief answer. 16.12. What is the ratio of the Net enrolment rate(%) of Least developed countries in 2005 to that in 2006?
Ensure brevity in your answer.  0.97. What is the ratio of the Net enrolment rate(%) of Pakistan in 2005 to that in 2006?
Make the answer very short. 1.04. What is the ratio of the Net enrolment rate(%) in Least developed countries in 2005 to that in 2007?
Provide a short and direct response. 0.95. What is the ratio of the Net enrolment rate(%) of Low & middle income in 2005 to that in 2007?
Keep it short and to the point. 0.98. What is the ratio of the Net enrolment rate(%) in Pakistan in 2005 to that in 2007?
Offer a terse response. 0.96. What is the ratio of the Net enrolment rate(%) of Arab World in 2005 to that in 2008?
Provide a succinct answer. 0.98. What is the ratio of the Net enrolment rate(%) of Least developed countries in 2005 to that in 2008?
Keep it short and to the point. 0.93. What is the ratio of the Net enrolment rate(%) in Low & middle income in 2005 to that in 2008?
Provide a short and direct response. 0.98. What is the ratio of the Net enrolment rate(%) in Pakistan in 2005 to that in 2008?
Provide a short and direct response. 0.94. What is the ratio of the Net enrolment rate(%) in Arab World in 2005 to that in 2009?
Your answer should be very brief. 0.97. What is the ratio of the Net enrolment rate(%) in Least developed countries in 2005 to that in 2009?
Your answer should be compact. 0.92. What is the ratio of the Net enrolment rate(%) of Low & middle income in 2005 to that in 2009?
Make the answer very short. 0.97. What is the ratio of the Net enrolment rate(%) in Pakistan in 2005 to that in 2009?
Your response must be concise. 0.91. What is the ratio of the Net enrolment rate(%) in Arab World in 2005 to that in 2010?
Provide a succinct answer. 0.96. What is the ratio of the Net enrolment rate(%) in Least developed countries in 2005 to that in 2010?
Offer a terse response. 0.92. What is the ratio of the Net enrolment rate(%) of Low & middle income in 2005 to that in 2010?
Provide a succinct answer. 0.97. What is the ratio of the Net enrolment rate(%) in Pakistan in 2005 to that in 2010?
Make the answer very short. 0.88. What is the ratio of the Net enrolment rate(%) of Arab World in 2005 to that in 2011?
Make the answer very short. 0.96. What is the ratio of the Net enrolment rate(%) in Least developed countries in 2005 to that in 2011?
Ensure brevity in your answer.  0.91. What is the ratio of the Net enrolment rate(%) of Low & middle income in 2005 to that in 2011?
Offer a very short reply. 0.97. What is the ratio of the Net enrolment rate(%) in Pakistan in 2005 to that in 2011?
Your answer should be compact. 0.91. What is the ratio of the Net enrolment rate(%) of Arab World in 2006 to that in 2007?
Make the answer very short. 1. What is the ratio of the Net enrolment rate(%) in Least developed countries in 2006 to that in 2007?
Ensure brevity in your answer.  0.98. What is the ratio of the Net enrolment rate(%) of Low & middle income in 2006 to that in 2007?
Offer a very short reply. 0.99. What is the ratio of the Net enrolment rate(%) of Pakistan in 2006 to that in 2007?
Provide a succinct answer. 0.93. What is the ratio of the Net enrolment rate(%) in Arab World in 2006 to that in 2008?
Your answer should be compact. 0.99. What is the ratio of the Net enrolment rate(%) of Least developed countries in 2006 to that in 2008?
Keep it short and to the point. 0.96. What is the ratio of the Net enrolment rate(%) in Low & middle income in 2006 to that in 2008?
Your answer should be compact. 0.98. What is the ratio of the Net enrolment rate(%) in Pakistan in 2006 to that in 2008?
Offer a very short reply. 0.91. What is the ratio of the Net enrolment rate(%) in Arab World in 2006 to that in 2009?
Provide a short and direct response. 0.98. What is the ratio of the Net enrolment rate(%) in Least developed countries in 2006 to that in 2009?
Your response must be concise. 0.95. What is the ratio of the Net enrolment rate(%) of Low & middle income in 2006 to that in 2009?
Offer a very short reply. 0.98. What is the ratio of the Net enrolment rate(%) of Pakistan in 2006 to that in 2009?
Offer a terse response. 0.88. What is the ratio of the Net enrolment rate(%) of Arab World in 2006 to that in 2010?
Your answer should be very brief. 0.97. What is the ratio of the Net enrolment rate(%) in Least developed countries in 2006 to that in 2010?
Make the answer very short. 0.95. What is the ratio of the Net enrolment rate(%) of Low & middle income in 2006 to that in 2010?
Your answer should be compact. 0.98. What is the ratio of the Net enrolment rate(%) of Pakistan in 2006 to that in 2010?
Your answer should be compact. 0.85. What is the ratio of the Net enrolment rate(%) in Arab World in 2006 to that in 2011?
Your response must be concise. 0.96. What is the ratio of the Net enrolment rate(%) in Least developed countries in 2006 to that in 2011?
Ensure brevity in your answer.  0.94. What is the ratio of the Net enrolment rate(%) of Low & middle income in 2006 to that in 2011?
Make the answer very short. 0.98. What is the ratio of the Net enrolment rate(%) in Pakistan in 2006 to that in 2011?
Provide a short and direct response. 0.88. What is the ratio of the Net enrolment rate(%) of Least developed countries in 2007 to that in 2008?
Offer a terse response. 0.97. What is the ratio of the Net enrolment rate(%) of Pakistan in 2007 to that in 2008?
Ensure brevity in your answer.  0.98. What is the ratio of the Net enrolment rate(%) of Arab World in 2007 to that in 2009?
Your answer should be compact. 0.98. What is the ratio of the Net enrolment rate(%) of Least developed countries in 2007 to that in 2009?
Offer a very short reply. 0.97. What is the ratio of the Net enrolment rate(%) of Pakistan in 2007 to that in 2009?
Your answer should be compact. 0.95. What is the ratio of the Net enrolment rate(%) in Arab World in 2007 to that in 2010?
Keep it short and to the point. 0.97. What is the ratio of the Net enrolment rate(%) in Least developed countries in 2007 to that in 2010?
Ensure brevity in your answer.  0.97. What is the ratio of the Net enrolment rate(%) in Pakistan in 2007 to that in 2010?
Provide a short and direct response. 0.92. What is the ratio of the Net enrolment rate(%) in Arab World in 2007 to that in 2011?
Offer a very short reply. 0.97. What is the ratio of the Net enrolment rate(%) of Least developed countries in 2007 to that in 2011?
Give a very brief answer. 0.95. What is the ratio of the Net enrolment rate(%) of Low & middle income in 2007 to that in 2011?
Give a very brief answer. 0.99. What is the ratio of the Net enrolment rate(%) of Pakistan in 2007 to that in 2011?
Provide a succinct answer. 0.94. What is the ratio of the Net enrolment rate(%) of Arab World in 2008 to that in 2009?
Your answer should be very brief. 0.99. What is the ratio of the Net enrolment rate(%) of Low & middle income in 2008 to that in 2009?
Keep it short and to the point. 1. What is the ratio of the Net enrolment rate(%) in Pakistan in 2008 to that in 2009?
Your answer should be compact. 0.97. What is the ratio of the Net enrolment rate(%) in Arab World in 2008 to that in 2010?
Offer a terse response. 0.98. What is the ratio of the Net enrolment rate(%) of Least developed countries in 2008 to that in 2010?
Your answer should be very brief. 0.99. What is the ratio of the Net enrolment rate(%) of Pakistan in 2008 to that in 2010?
Your answer should be compact. 0.94. What is the ratio of the Net enrolment rate(%) of Arab World in 2008 to that in 2011?
Your answer should be very brief. 0.98. What is the ratio of the Net enrolment rate(%) of Least developed countries in 2008 to that in 2011?
Make the answer very short. 0.98. What is the ratio of the Net enrolment rate(%) of Pakistan in 2008 to that in 2011?
Provide a short and direct response. 0.96. What is the ratio of the Net enrolment rate(%) in Arab World in 2009 to that in 2010?
Ensure brevity in your answer.  0.99. What is the ratio of the Net enrolment rate(%) of Least developed countries in 2009 to that in 2010?
Ensure brevity in your answer.  1. What is the ratio of the Net enrolment rate(%) of Pakistan in 2009 to that in 2010?
Offer a terse response. 0.97. What is the ratio of the Net enrolment rate(%) in Least developed countries in 2009 to that in 2011?
Your answer should be compact. 0.99. What is the ratio of the Net enrolment rate(%) of Pakistan in 2010 to that in 2011?
Provide a short and direct response. 1.03. What is the difference between the highest and the second highest Net enrolment rate(%) in Arab World?
Offer a very short reply. 0.17. What is the difference between the highest and the second highest Net enrolment rate(%) in Least developed countries?
Make the answer very short. 0.88. What is the difference between the highest and the second highest Net enrolment rate(%) of Low & middle income?
Provide a succinct answer. 0.01. What is the difference between the highest and the second highest Net enrolment rate(%) in Pakistan?
Your answer should be very brief. 1.97. What is the difference between the highest and the lowest Net enrolment rate(%) in Arab World?
Offer a terse response. 3.67. What is the difference between the highest and the lowest Net enrolment rate(%) in Least developed countries?
Your answer should be very brief. 7.11. What is the difference between the highest and the lowest Net enrolment rate(%) of Low & middle income?
Give a very brief answer. 2.49. What is the difference between the highest and the lowest Net enrolment rate(%) in Pakistan?
Give a very brief answer. 10.94. 